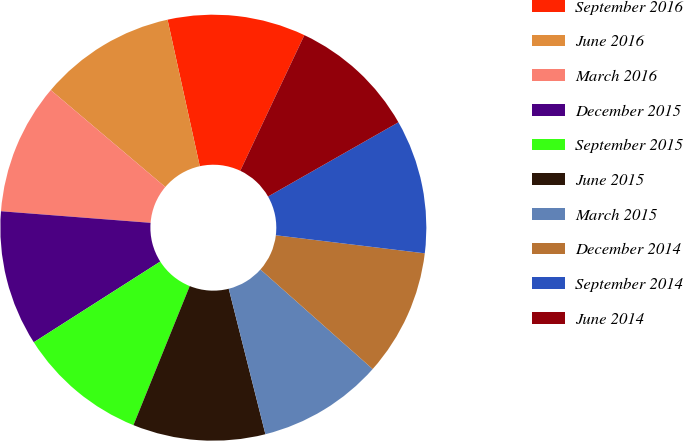Convert chart. <chart><loc_0><loc_0><loc_500><loc_500><pie_chart><fcel>September 2016<fcel>June 2016<fcel>March 2016<fcel>December 2015<fcel>September 2015<fcel>June 2015<fcel>March 2015<fcel>December 2014<fcel>September 2014<fcel>June 2014<nl><fcel>10.48%<fcel>10.37%<fcel>9.95%<fcel>10.27%<fcel>9.84%<fcel>10.05%<fcel>9.52%<fcel>9.63%<fcel>10.16%<fcel>9.73%<nl></chart> 